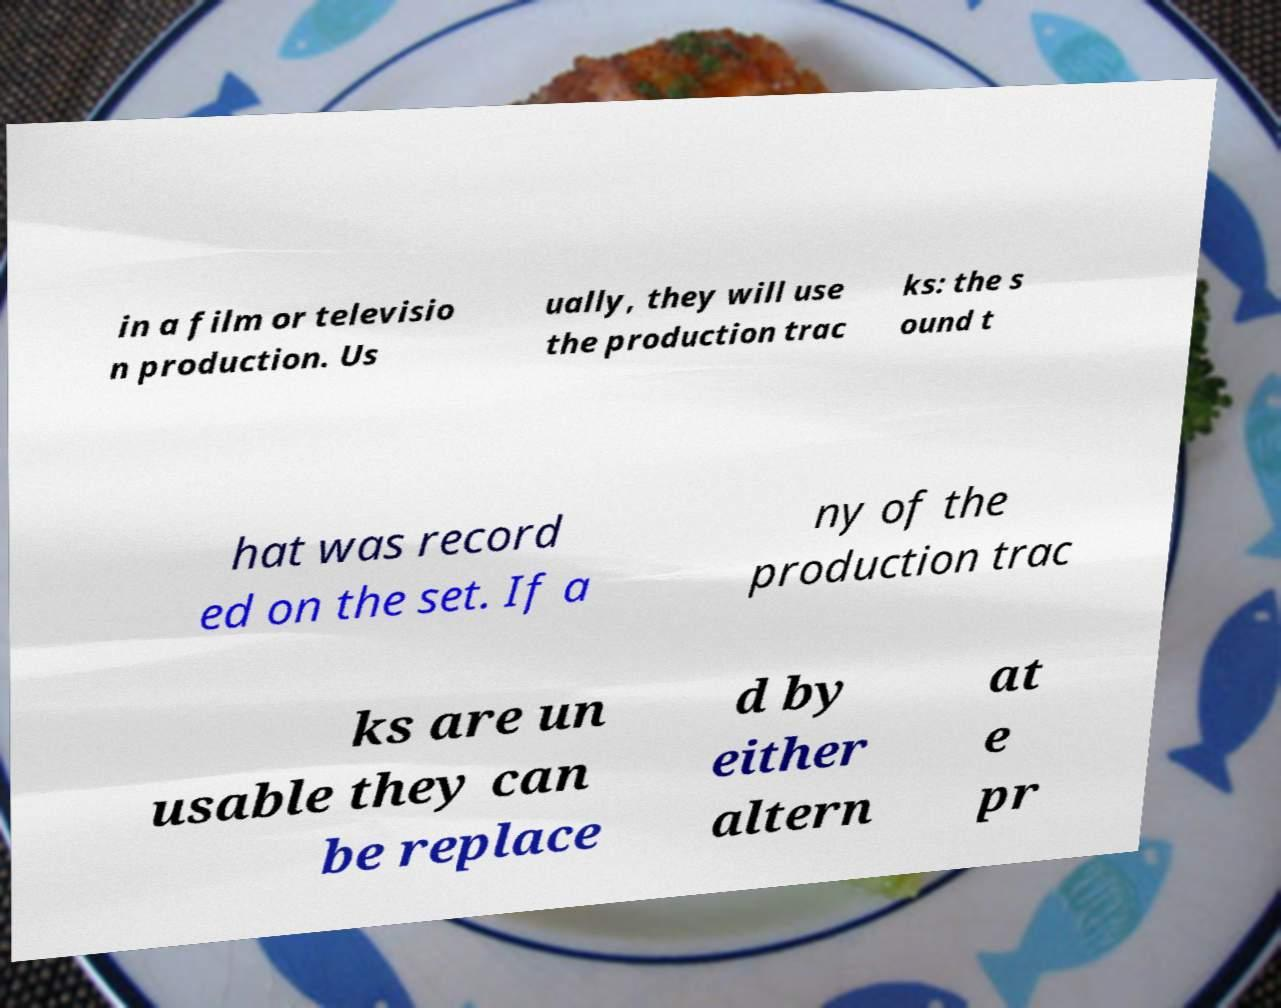Can you accurately transcribe the text from the provided image for me? in a film or televisio n production. Us ually, they will use the production trac ks: the s ound t hat was record ed on the set. If a ny of the production trac ks are un usable they can be replace d by either altern at e pr 